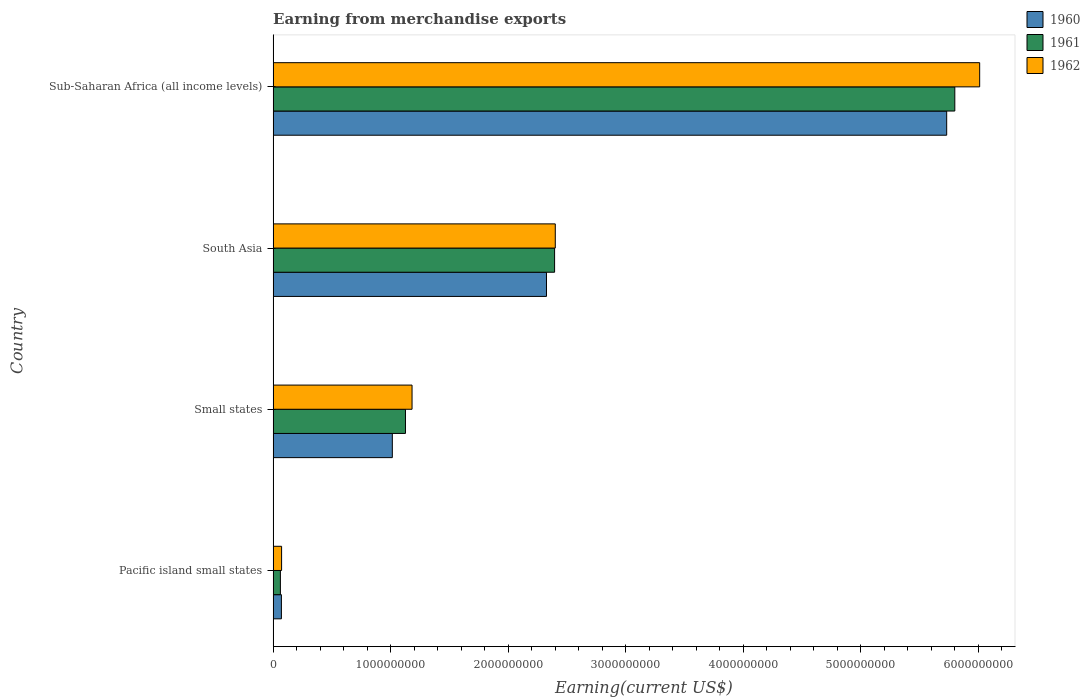What is the label of the 2nd group of bars from the top?
Offer a very short reply. South Asia. In how many cases, is the number of bars for a given country not equal to the number of legend labels?
Offer a very short reply. 0. What is the amount earned from merchandise exports in 1960 in South Asia?
Make the answer very short. 2.33e+09. Across all countries, what is the maximum amount earned from merchandise exports in 1960?
Your answer should be compact. 5.73e+09. Across all countries, what is the minimum amount earned from merchandise exports in 1961?
Provide a succinct answer. 6.18e+07. In which country was the amount earned from merchandise exports in 1962 maximum?
Offer a very short reply. Sub-Saharan Africa (all income levels). In which country was the amount earned from merchandise exports in 1961 minimum?
Provide a short and direct response. Pacific island small states. What is the total amount earned from merchandise exports in 1961 in the graph?
Ensure brevity in your answer.  9.38e+09. What is the difference between the amount earned from merchandise exports in 1960 in Small states and that in Sub-Saharan Africa (all income levels)?
Ensure brevity in your answer.  -4.72e+09. What is the difference between the amount earned from merchandise exports in 1960 in Sub-Saharan Africa (all income levels) and the amount earned from merchandise exports in 1961 in Pacific island small states?
Give a very brief answer. 5.67e+09. What is the average amount earned from merchandise exports in 1961 per country?
Provide a succinct answer. 2.35e+09. What is the difference between the amount earned from merchandise exports in 1960 and amount earned from merchandise exports in 1961 in Sub-Saharan Africa (all income levels)?
Offer a terse response. -6.91e+07. In how many countries, is the amount earned from merchandise exports in 1961 greater than 200000000 US$?
Your answer should be compact. 3. What is the ratio of the amount earned from merchandise exports in 1960 in Pacific island small states to that in Small states?
Keep it short and to the point. 0.07. Is the difference between the amount earned from merchandise exports in 1960 in Small states and Sub-Saharan Africa (all income levels) greater than the difference between the amount earned from merchandise exports in 1961 in Small states and Sub-Saharan Africa (all income levels)?
Keep it short and to the point. No. What is the difference between the highest and the second highest amount earned from merchandise exports in 1962?
Provide a succinct answer. 3.61e+09. What is the difference between the highest and the lowest amount earned from merchandise exports in 1962?
Keep it short and to the point. 5.94e+09. Is the sum of the amount earned from merchandise exports in 1960 in South Asia and Sub-Saharan Africa (all income levels) greater than the maximum amount earned from merchandise exports in 1961 across all countries?
Provide a short and direct response. Yes. What does the 1st bar from the bottom in South Asia represents?
Your answer should be very brief. 1960. Is it the case that in every country, the sum of the amount earned from merchandise exports in 1960 and amount earned from merchandise exports in 1962 is greater than the amount earned from merchandise exports in 1961?
Your response must be concise. Yes. How many countries are there in the graph?
Your answer should be compact. 4. Are the values on the major ticks of X-axis written in scientific E-notation?
Keep it short and to the point. No. Does the graph contain any zero values?
Make the answer very short. No. Does the graph contain grids?
Your answer should be very brief. No. Where does the legend appear in the graph?
Offer a terse response. Top right. What is the title of the graph?
Offer a terse response. Earning from merchandise exports. Does "1990" appear as one of the legend labels in the graph?
Offer a terse response. No. What is the label or title of the X-axis?
Your response must be concise. Earning(current US$). What is the Earning(current US$) of 1960 in Pacific island small states?
Provide a short and direct response. 7.05e+07. What is the Earning(current US$) in 1961 in Pacific island small states?
Ensure brevity in your answer.  6.18e+07. What is the Earning(current US$) of 1962 in Pacific island small states?
Keep it short and to the point. 7.21e+07. What is the Earning(current US$) in 1960 in Small states?
Provide a short and direct response. 1.01e+09. What is the Earning(current US$) in 1961 in Small states?
Make the answer very short. 1.13e+09. What is the Earning(current US$) of 1962 in Small states?
Make the answer very short. 1.18e+09. What is the Earning(current US$) in 1960 in South Asia?
Give a very brief answer. 2.33e+09. What is the Earning(current US$) of 1961 in South Asia?
Keep it short and to the point. 2.39e+09. What is the Earning(current US$) of 1962 in South Asia?
Make the answer very short. 2.40e+09. What is the Earning(current US$) of 1960 in Sub-Saharan Africa (all income levels)?
Offer a very short reply. 5.73e+09. What is the Earning(current US$) of 1961 in Sub-Saharan Africa (all income levels)?
Offer a terse response. 5.80e+09. What is the Earning(current US$) of 1962 in Sub-Saharan Africa (all income levels)?
Ensure brevity in your answer.  6.01e+09. Across all countries, what is the maximum Earning(current US$) of 1960?
Your answer should be very brief. 5.73e+09. Across all countries, what is the maximum Earning(current US$) in 1961?
Give a very brief answer. 5.80e+09. Across all countries, what is the maximum Earning(current US$) in 1962?
Provide a succinct answer. 6.01e+09. Across all countries, what is the minimum Earning(current US$) in 1960?
Offer a very short reply. 7.05e+07. Across all countries, what is the minimum Earning(current US$) of 1961?
Make the answer very short. 6.18e+07. Across all countries, what is the minimum Earning(current US$) of 1962?
Offer a very short reply. 7.21e+07. What is the total Earning(current US$) in 1960 in the graph?
Your response must be concise. 9.14e+09. What is the total Earning(current US$) of 1961 in the graph?
Your answer should be very brief. 9.38e+09. What is the total Earning(current US$) of 1962 in the graph?
Provide a succinct answer. 9.67e+09. What is the difference between the Earning(current US$) in 1960 in Pacific island small states and that in Small states?
Your answer should be very brief. -9.44e+08. What is the difference between the Earning(current US$) of 1961 in Pacific island small states and that in Small states?
Make the answer very short. -1.06e+09. What is the difference between the Earning(current US$) of 1962 in Pacific island small states and that in Small states?
Keep it short and to the point. -1.11e+09. What is the difference between the Earning(current US$) of 1960 in Pacific island small states and that in South Asia?
Your response must be concise. -2.26e+09. What is the difference between the Earning(current US$) of 1961 in Pacific island small states and that in South Asia?
Your response must be concise. -2.33e+09. What is the difference between the Earning(current US$) of 1962 in Pacific island small states and that in South Asia?
Offer a very short reply. -2.33e+09. What is the difference between the Earning(current US$) in 1960 in Pacific island small states and that in Sub-Saharan Africa (all income levels)?
Provide a succinct answer. -5.66e+09. What is the difference between the Earning(current US$) in 1961 in Pacific island small states and that in Sub-Saharan Africa (all income levels)?
Your answer should be compact. -5.74e+09. What is the difference between the Earning(current US$) of 1962 in Pacific island small states and that in Sub-Saharan Africa (all income levels)?
Provide a short and direct response. -5.94e+09. What is the difference between the Earning(current US$) of 1960 in Small states and that in South Asia?
Provide a short and direct response. -1.31e+09. What is the difference between the Earning(current US$) of 1961 in Small states and that in South Asia?
Give a very brief answer. -1.27e+09. What is the difference between the Earning(current US$) in 1962 in Small states and that in South Asia?
Offer a terse response. -1.22e+09. What is the difference between the Earning(current US$) in 1960 in Small states and that in Sub-Saharan Africa (all income levels)?
Ensure brevity in your answer.  -4.72e+09. What is the difference between the Earning(current US$) of 1961 in Small states and that in Sub-Saharan Africa (all income levels)?
Offer a very short reply. -4.67e+09. What is the difference between the Earning(current US$) in 1962 in Small states and that in Sub-Saharan Africa (all income levels)?
Make the answer very short. -4.83e+09. What is the difference between the Earning(current US$) of 1960 in South Asia and that in Sub-Saharan Africa (all income levels)?
Provide a succinct answer. -3.40e+09. What is the difference between the Earning(current US$) of 1961 in South Asia and that in Sub-Saharan Africa (all income levels)?
Keep it short and to the point. -3.40e+09. What is the difference between the Earning(current US$) in 1962 in South Asia and that in Sub-Saharan Africa (all income levels)?
Your answer should be very brief. -3.61e+09. What is the difference between the Earning(current US$) in 1960 in Pacific island small states and the Earning(current US$) in 1961 in Small states?
Your answer should be very brief. -1.06e+09. What is the difference between the Earning(current US$) of 1960 in Pacific island small states and the Earning(current US$) of 1962 in Small states?
Give a very brief answer. -1.11e+09. What is the difference between the Earning(current US$) of 1961 in Pacific island small states and the Earning(current US$) of 1962 in Small states?
Give a very brief answer. -1.12e+09. What is the difference between the Earning(current US$) in 1960 in Pacific island small states and the Earning(current US$) in 1961 in South Asia?
Keep it short and to the point. -2.32e+09. What is the difference between the Earning(current US$) in 1960 in Pacific island small states and the Earning(current US$) in 1962 in South Asia?
Ensure brevity in your answer.  -2.33e+09. What is the difference between the Earning(current US$) in 1961 in Pacific island small states and the Earning(current US$) in 1962 in South Asia?
Make the answer very short. -2.34e+09. What is the difference between the Earning(current US$) of 1960 in Pacific island small states and the Earning(current US$) of 1961 in Sub-Saharan Africa (all income levels)?
Keep it short and to the point. -5.73e+09. What is the difference between the Earning(current US$) of 1960 in Pacific island small states and the Earning(current US$) of 1962 in Sub-Saharan Africa (all income levels)?
Offer a terse response. -5.94e+09. What is the difference between the Earning(current US$) of 1961 in Pacific island small states and the Earning(current US$) of 1962 in Sub-Saharan Africa (all income levels)?
Your answer should be compact. -5.95e+09. What is the difference between the Earning(current US$) in 1960 in Small states and the Earning(current US$) in 1961 in South Asia?
Keep it short and to the point. -1.38e+09. What is the difference between the Earning(current US$) in 1960 in Small states and the Earning(current US$) in 1962 in South Asia?
Offer a terse response. -1.39e+09. What is the difference between the Earning(current US$) in 1961 in Small states and the Earning(current US$) in 1962 in South Asia?
Your answer should be compact. -1.27e+09. What is the difference between the Earning(current US$) of 1960 in Small states and the Earning(current US$) of 1961 in Sub-Saharan Africa (all income levels)?
Keep it short and to the point. -4.79e+09. What is the difference between the Earning(current US$) in 1960 in Small states and the Earning(current US$) in 1962 in Sub-Saharan Africa (all income levels)?
Give a very brief answer. -5.00e+09. What is the difference between the Earning(current US$) in 1961 in Small states and the Earning(current US$) in 1962 in Sub-Saharan Africa (all income levels)?
Provide a succinct answer. -4.89e+09. What is the difference between the Earning(current US$) of 1960 in South Asia and the Earning(current US$) of 1961 in Sub-Saharan Africa (all income levels)?
Keep it short and to the point. -3.47e+09. What is the difference between the Earning(current US$) of 1960 in South Asia and the Earning(current US$) of 1962 in Sub-Saharan Africa (all income levels)?
Your response must be concise. -3.69e+09. What is the difference between the Earning(current US$) in 1961 in South Asia and the Earning(current US$) in 1962 in Sub-Saharan Africa (all income levels)?
Your response must be concise. -3.62e+09. What is the average Earning(current US$) in 1960 per country?
Offer a very short reply. 2.29e+09. What is the average Earning(current US$) in 1961 per country?
Provide a succinct answer. 2.35e+09. What is the average Earning(current US$) in 1962 per country?
Make the answer very short. 2.42e+09. What is the difference between the Earning(current US$) of 1960 and Earning(current US$) of 1961 in Pacific island small states?
Ensure brevity in your answer.  8.67e+06. What is the difference between the Earning(current US$) of 1960 and Earning(current US$) of 1962 in Pacific island small states?
Provide a succinct answer. -1.58e+06. What is the difference between the Earning(current US$) of 1961 and Earning(current US$) of 1962 in Pacific island small states?
Your answer should be very brief. -1.03e+07. What is the difference between the Earning(current US$) of 1960 and Earning(current US$) of 1961 in Small states?
Provide a short and direct response. -1.12e+08. What is the difference between the Earning(current US$) of 1960 and Earning(current US$) of 1962 in Small states?
Your response must be concise. -1.68e+08. What is the difference between the Earning(current US$) of 1961 and Earning(current US$) of 1962 in Small states?
Provide a short and direct response. -5.59e+07. What is the difference between the Earning(current US$) in 1960 and Earning(current US$) in 1961 in South Asia?
Give a very brief answer. -6.90e+07. What is the difference between the Earning(current US$) of 1960 and Earning(current US$) of 1962 in South Asia?
Keep it short and to the point. -7.49e+07. What is the difference between the Earning(current US$) in 1961 and Earning(current US$) in 1962 in South Asia?
Offer a very short reply. -5.88e+06. What is the difference between the Earning(current US$) in 1960 and Earning(current US$) in 1961 in Sub-Saharan Africa (all income levels)?
Your response must be concise. -6.91e+07. What is the difference between the Earning(current US$) in 1960 and Earning(current US$) in 1962 in Sub-Saharan Africa (all income levels)?
Ensure brevity in your answer.  -2.81e+08. What is the difference between the Earning(current US$) in 1961 and Earning(current US$) in 1962 in Sub-Saharan Africa (all income levels)?
Your answer should be very brief. -2.12e+08. What is the ratio of the Earning(current US$) of 1960 in Pacific island small states to that in Small states?
Provide a short and direct response. 0.07. What is the ratio of the Earning(current US$) of 1961 in Pacific island small states to that in Small states?
Your answer should be compact. 0.05. What is the ratio of the Earning(current US$) in 1962 in Pacific island small states to that in Small states?
Keep it short and to the point. 0.06. What is the ratio of the Earning(current US$) of 1960 in Pacific island small states to that in South Asia?
Make the answer very short. 0.03. What is the ratio of the Earning(current US$) of 1961 in Pacific island small states to that in South Asia?
Provide a succinct answer. 0.03. What is the ratio of the Earning(current US$) of 1960 in Pacific island small states to that in Sub-Saharan Africa (all income levels)?
Make the answer very short. 0.01. What is the ratio of the Earning(current US$) of 1961 in Pacific island small states to that in Sub-Saharan Africa (all income levels)?
Offer a very short reply. 0.01. What is the ratio of the Earning(current US$) in 1962 in Pacific island small states to that in Sub-Saharan Africa (all income levels)?
Ensure brevity in your answer.  0.01. What is the ratio of the Earning(current US$) in 1960 in Small states to that in South Asia?
Keep it short and to the point. 0.44. What is the ratio of the Earning(current US$) in 1961 in Small states to that in South Asia?
Make the answer very short. 0.47. What is the ratio of the Earning(current US$) in 1962 in Small states to that in South Asia?
Make the answer very short. 0.49. What is the ratio of the Earning(current US$) of 1960 in Small states to that in Sub-Saharan Africa (all income levels)?
Your response must be concise. 0.18. What is the ratio of the Earning(current US$) of 1961 in Small states to that in Sub-Saharan Africa (all income levels)?
Provide a succinct answer. 0.19. What is the ratio of the Earning(current US$) in 1962 in Small states to that in Sub-Saharan Africa (all income levels)?
Offer a very short reply. 0.2. What is the ratio of the Earning(current US$) of 1960 in South Asia to that in Sub-Saharan Africa (all income levels)?
Keep it short and to the point. 0.41. What is the ratio of the Earning(current US$) of 1961 in South Asia to that in Sub-Saharan Africa (all income levels)?
Your answer should be compact. 0.41. What is the ratio of the Earning(current US$) in 1962 in South Asia to that in Sub-Saharan Africa (all income levels)?
Your answer should be compact. 0.4. What is the difference between the highest and the second highest Earning(current US$) in 1960?
Ensure brevity in your answer.  3.40e+09. What is the difference between the highest and the second highest Earning(current US$) in 1961?
Offer a terse response. 3.40e+09. What is the difference between the highest and the second highest Earning(current US$) of 1962?
Your answer should be compact. 3.61e+09. What is the difference between the highest and the lowest Earning(current US$) in 1960?
Offer a very short reply. 5.66e+09. What is the difference between the highest and the lowest Earning(current US$) in 1961?
Offer a very short reply. 5.74e+09. What is the difference between the highest and the lowest Earning(current US$) in 1962?
Give a very brief answer. 5.94e+09. 